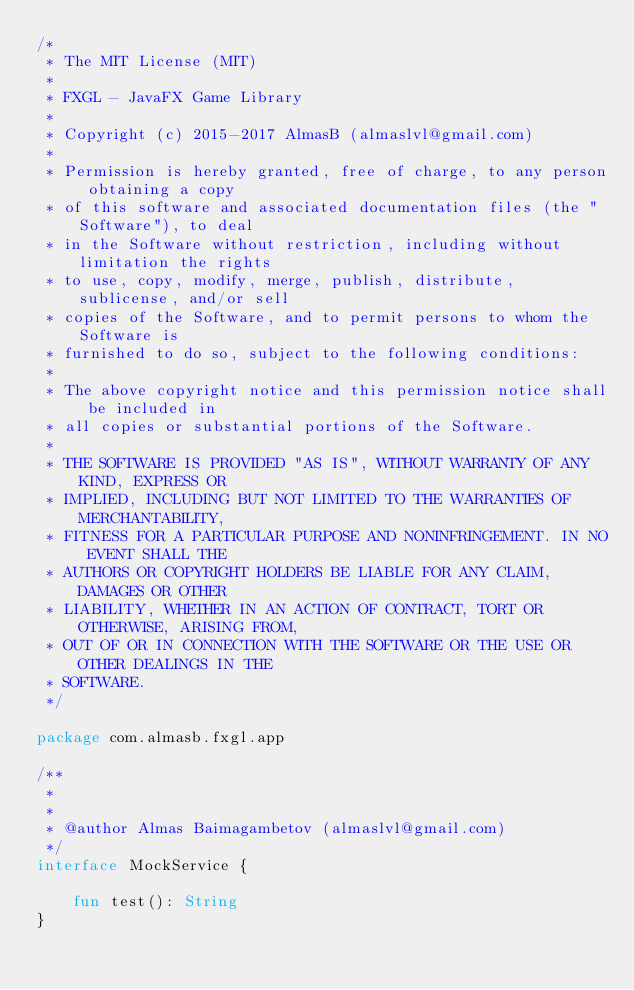Convert code to text. <code><loc_0><loc_0><loc_500><loc_500><_Kotlin_>/*
 * The MIT License (MIT)
 *
 * FXGL - JavaFX Game Library
 *
 * Copyright (c) 2015-2017 AlmasB (almaslvl@gmail.com)
 *
 * Permission is hereby granted, free of charge, to any person obtaining a copy
 * of this software and associated documentation files (the "Software"), to deal
 * in the Software without restriction, including without limitation the rights
 * to use, copy, modify, merge, publish, distribute, sublicense, and/or sell
 * copies of the Software, and to permit persons to whom the Software is
 * furnished to do so, subject to the following conditions:
 *
 * The above copyright notice and this permission notice shall be included in
 * all copies or substantial portions of the Software.
 *
 * THE SOFTWARE IS PROVIDED "AS IS", WITHOUT WARRANTY OF ANY KIND, EXPRESS OR
 * IMPLIED, INCLUDING BUT NOT LIMITED TO THE WARRANTIES OF MERCHANTABILITY,
 * FITNESS FOR A PARTICULAR PURPOSE AND NONINFRINGEMENT. IN NO EVENT SHALL THE
 * AUTHORS OR COPYRIGHT HOLDERS BE LIABLE FOR ANY CLAIM, DAMAGES OR OTHER
 * LIABILITY, WHETHER IN AN ACTION OF CONTRACT, TORT OR OTHERWISE, ARISING FROM,
 * OUT OF OR IN CONNECTION WITH THE SOFTWARE OR THE USE OR OTHER DEALINGS IN THE
 * SOFTWARE.
 */

package com.almasb.fxgl.app

/**
 *
 *
 * @author Almas Baimagambetov (almaslvl@gmail.com)
 */
interface MockService {

    fun test(): String
}</code> 